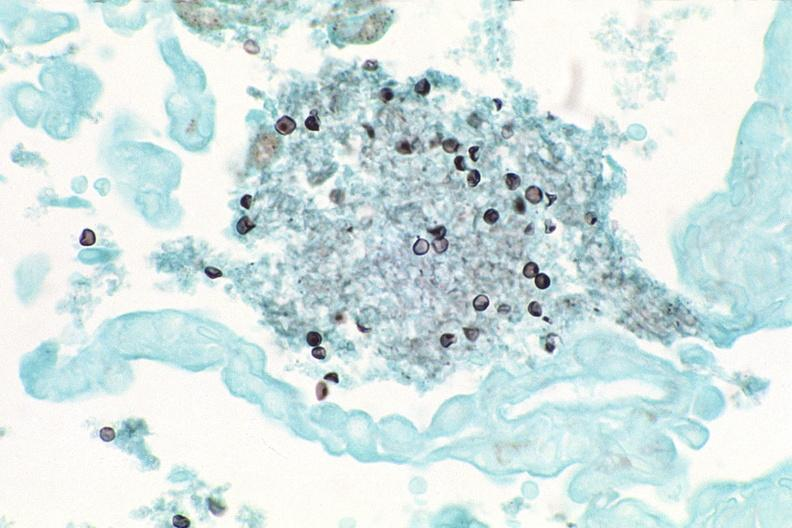s respiratory present?
Answer the question using a single word or phrase. Yes 